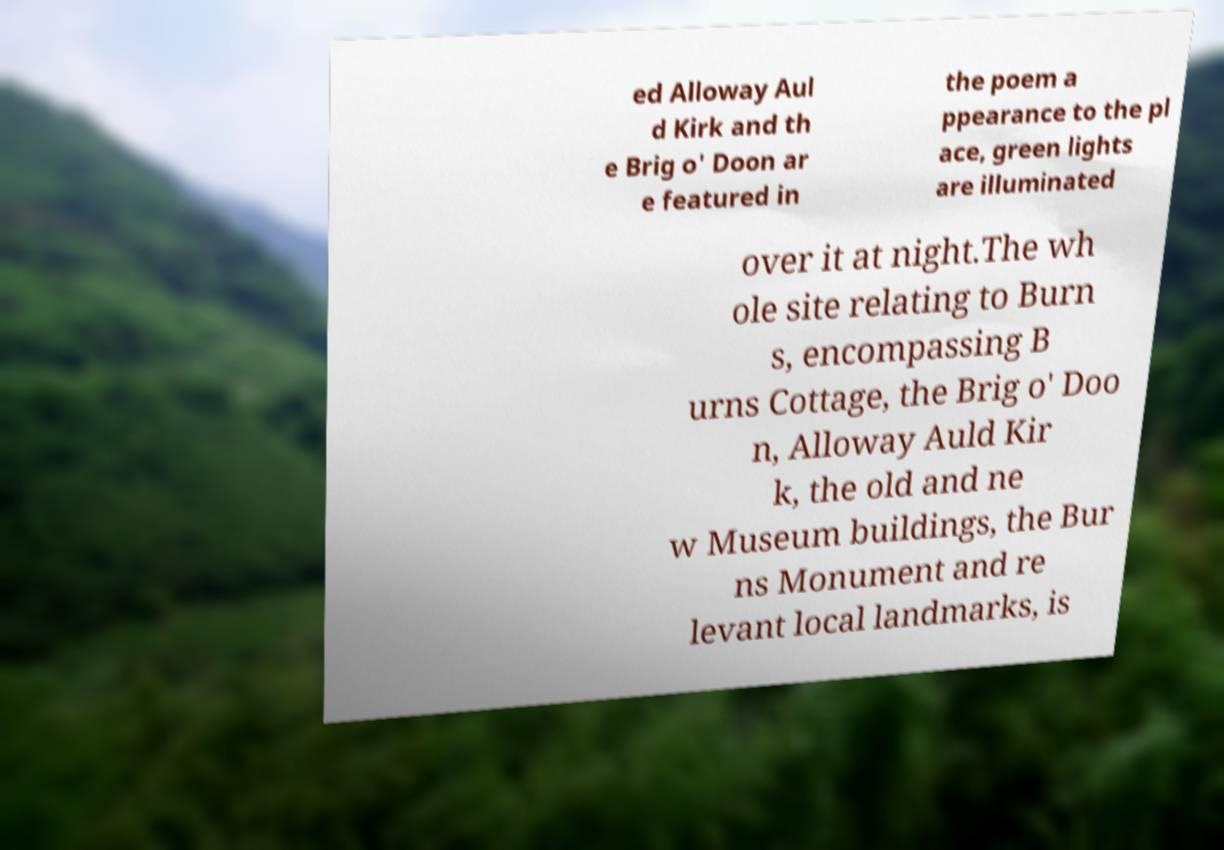Can you read and provide the text displayed in the image?This photo seems to have some interesting text. Can you extract and type it out for me? ed Alloway Aul d Kirk and th e Brig o' Doon ar e featured in the poem a ppearance to the pl ace, green lights are illuminated over it at night.The wh ole site relating to Burn s, encompassing B urns Cottage, the Brig o' Doo n, Alloway Auld Kir k, the old and ne w Museum buildings, the Bur ns Monument and re levant local landmarks, is 